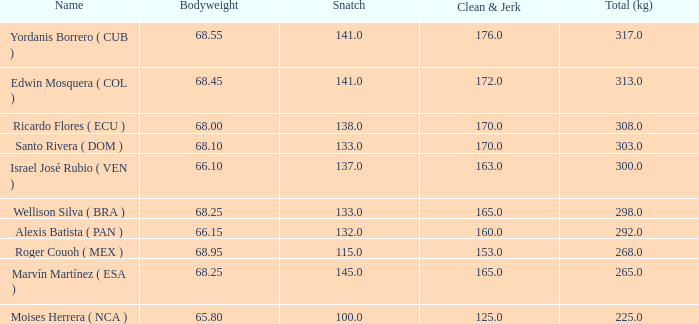Would you be able to parse every entry in this table? {'header': ['Name', 'Bodyweight', 'Snatch', 'Clean & Jerk', 'Total (kg)'], 'rows': [['Yordanis Borrero ( CUB )', '68.55', '141.0', '176.0', '317.0'], ['Edwin Mosquera ( COL )', '68.45', '141.0', '172.0', '313.0'], ['Ricardo Flores ( ECU )', '68.00', '138.0', '170.0', '308.0'], ['Santo Rivera ( DOM )', '68.10', '133.0', '170.0', '303.0'], ['Israel José Rubio ( VEN )', '66.10', '137.0', '163.0', '300.0'], ['Wellison Silva ( BRA )', '68.25', '133.0', '165.0', '298.0'], ['Alexis Batista ( PAN )', '66.15', '132.0', '160.0', '292.0'], ['Roger Couoh ( MEX )', '68.95', '115.0', '153.0', '268.0'], ['Marvín Martínez ( ESA )', '68.25', '145.0', '165.0', '265.0'], ['Moises Herrera ( NCA )', '65.80', '100.0', '125.0', '225.0']]} Which Total (kg) has a Clean & Jerk smaller than 153, and a Snatch smaller than 100? None. 